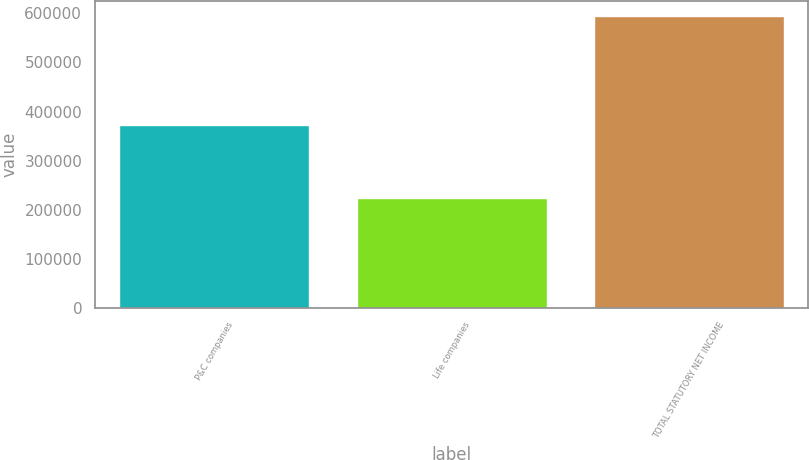<chart> <loc_0><loc_0><loc_500><loc_500><bar_chart><fcel>P&C companies<fcel>Life companies<fcel>TOTAL STATUTORY NET INCOME<nl><fcel>371520<fcel>223519<fcel>595039<nl></chart> 